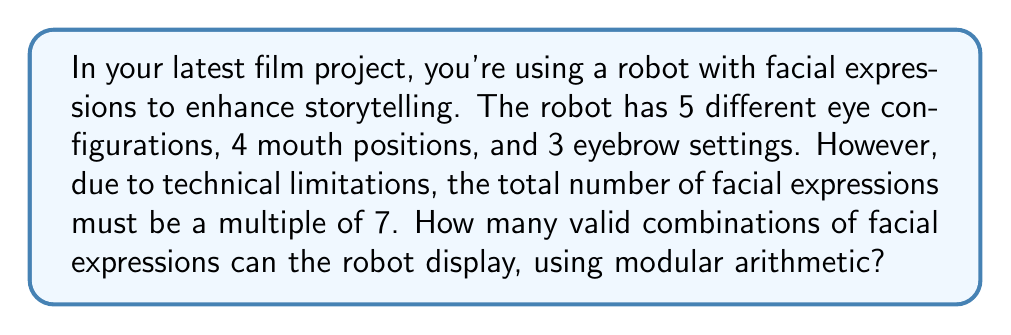Give your solution to this math problem. Let's approach this step-by-step:

1) First, calculate the total number of possible combinations without the modular restriction:
   $$ 5 \times 4 \times 3 = 60 $$

2) We need to find the largest multiple of 7 that is less than or equal to 60. We can use the modulo operation for this:
   $$ 60 \equiv r \pmod{7} $$
   where $r$ is the remainder we need to find.

3) Divide 60 by 7:
   $$ 60 \div 7 = 8 \text{ remainder } 4 $$
   So, $r = 4$

4) The largest multiple of 7 less than or equal to 60 is:
   $$ 60 - 4 = 56 $$

5) Therefore, the number of valid combinations is 56.

6) We can verify this using modular arithmetic:
   $$ 56 \equiv 0 \pmod{7} $$

Thus, 56 is the largest number of combinations that satisfies the requirements.
Answer: 56 